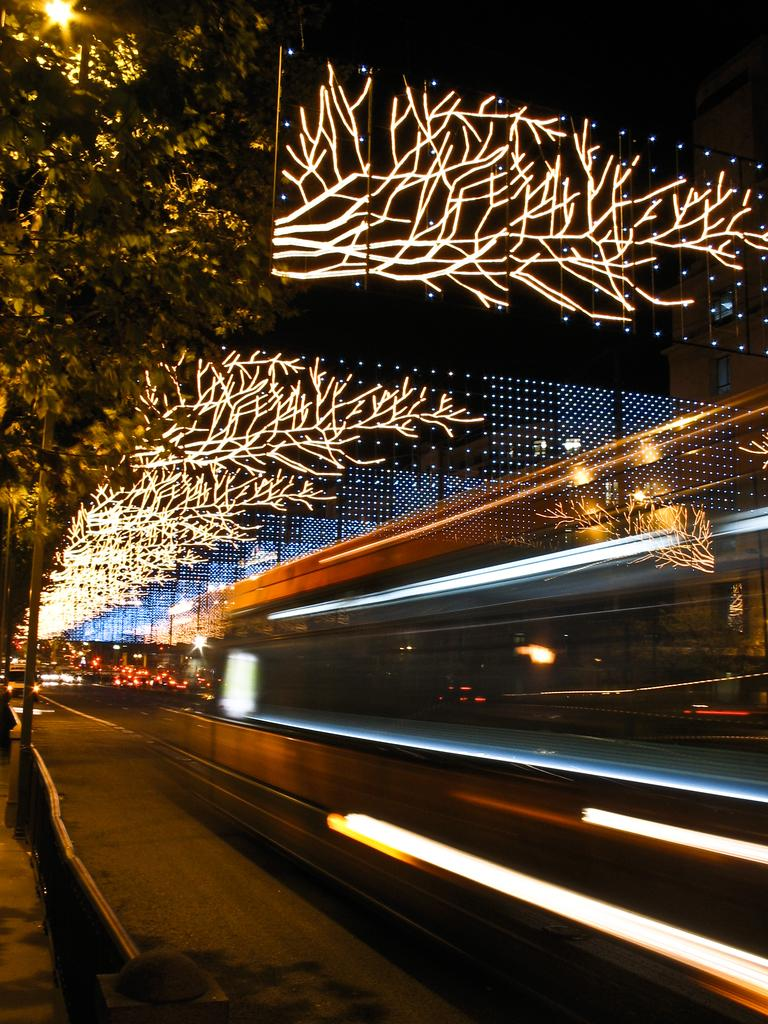What is the main feature of the image? There is a road in the image. What else can be seen in the image besides the road? There are lights as decoration, a tree, and a pole in the image. How would you describe the lighting in the image? The image appears to be slightly dark in the background. How many heads of wilderness animals can be seen in the image? There are no wilderness animals or heads present in the image. 